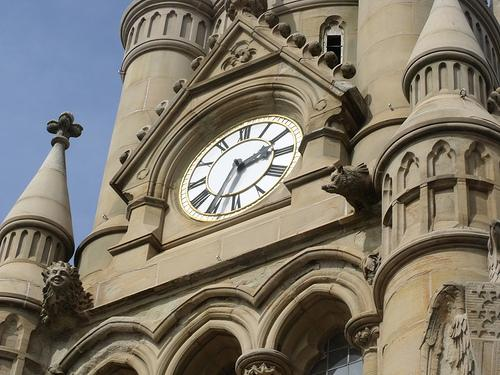Imagine you're describing this image to someone over the phone. What would you say? It's a picture of an old clock tower that has a big white clock with Roman numerals on it, along with statues and gargoyles all around. State the central feature of the image along with a few other interesting details in a single sentence. The image displays a vintage clock tower with a white face, Roman numerals, and an array of stone statues and designs. Explain the primary focus in the image and the different elements which give it a unique appearance. The main focus is on a clock tower with an elegant white clock face with Roman numerals, accompanied by various statues, gargoyles, and stone flourishes. Give a concise explanation of the image while focusing on architectural elements. An intricately designed stone tower features a white clock face, Roman numerals, multiple statues, gargoyles, and various stone formations. Describe the scene in the picture using casual language. There's this cool old building with a big white clock up top, with Roman numerals and all, plus some rad statues and gargoyles hanging about. Provide a brief description of the most prominent features in the image. A clock tower adorned with statues, gargoyles, and stone designs, featuring a white clock face with Roman numerals and black clock hands. Describe the image objectively, with an emphasis on the large clock. The image depicts a clock tower with a prominent white clock face that has black Roman numerals and two black hands against a stone background. Using poetic language, describe the main features of the image. An ancient tower, adorned with stone faces and creatures, holds a timeless sentinel, a clock of white, counting hours with unmoving grace. Mention the central object in the image along with its key details. At the center of the image is a large clock with a white face, black Roman numerals, and two black clock hands, set on a stone tower. Write a simple sentence summarizing the main subject of the image. The image shows a clock tower with a white clock face featuring Roman numerals and various statues. 